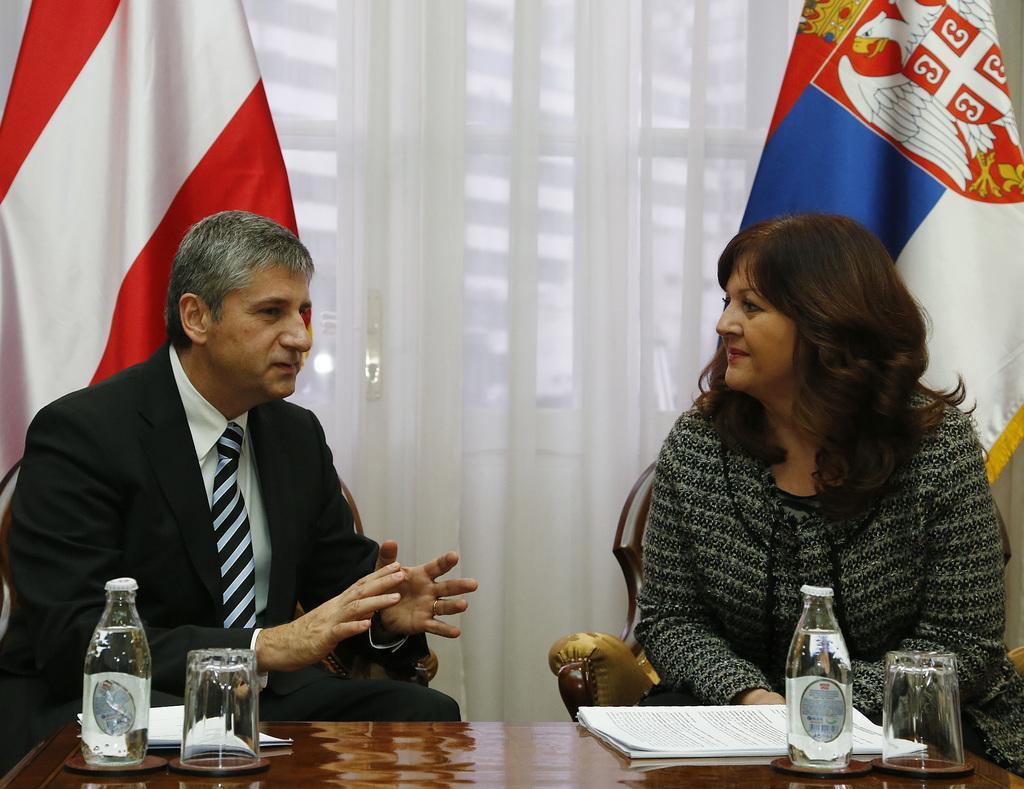Describe this image in one or two sentences. In this image I can see a woman wearing grey and black colored dress and a man wearing white and black colored dress are sitting on couches in front of a brown colored table. On the table I can see two glasses, two bottles and few papers. In the background I can see the white colored curtain and two flags. 